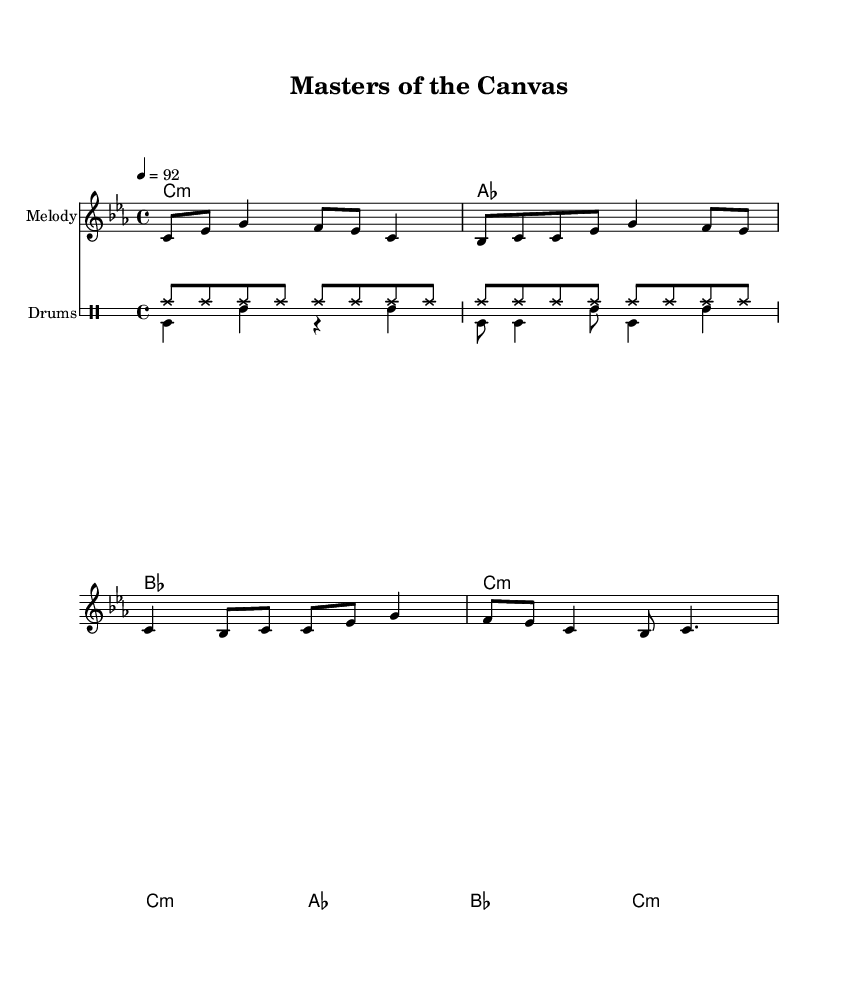What is the key signature of this music? The key signature is C minor, indicated by the presence of three flat notes (B, E, and A) which are a part of the C minor scale.
Answer: C minor What is the time signature of this music? The time signature is 4/4, which means there are four beats in a measure and the quarter note gets one beat. This is indicated at the beginning of the score.
Answer: 4/4 What is the tempo for this piece? The tempo is marked as quarter note equals 92, which indicates the speed at which the piece should be played.
Answer: 92 How many measures are in the melody? There are eight measures in the melody, which can be counted by looking at the grouping of notes and the bar lines separating each measure.
Answer: 8 What is the rhythmic pattern for the drums in this piece? The drum pattern consists of a repeated hi-hat pattern followed by a bass drum and snare pattern. The hi-hat plays consistent eighth notes while the bass and snare create a more varied rhythmic effect.
Answer: Hi-hat and bass/snare pattern Which famous painters are mentioned in the lyrics? The lyrics mention Van Gogh, Monet, and Leonardo, who are iconic figures in art history known for their distinct styles and contributions.
Answer: Van Gogh, Monet, and Leonardo 